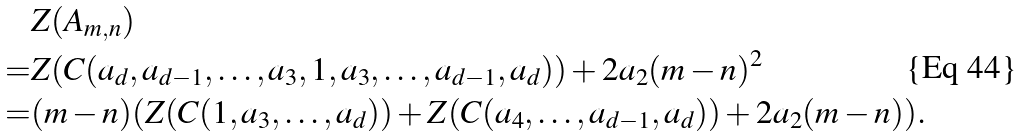Convert formula to latex. <formula><loc_0><loc_0><loc_500><loc_500>& Z ( A _ { m , n } ) \\ = & Z ( C ( a _ { d } , a _ { d - 1 } , \dots , a _ { 3 } , 1 , a _ { 3 } , \dots , a _ { d - 1 } , a _ { d } ) ) + 2 a _ { 2 } ( m - n ) ^ { 2 } \\ = & ( m - n ) ( Z ( C ( 1 , a _ { 3 } , \dots , a _ { d } ) ) + Z ( C ( a _ { 4 } , \dots , a _ { d - 1 } , a _ { d } ) ) + 2 a _ { 2 } ( m - n ) ) .</formula> 